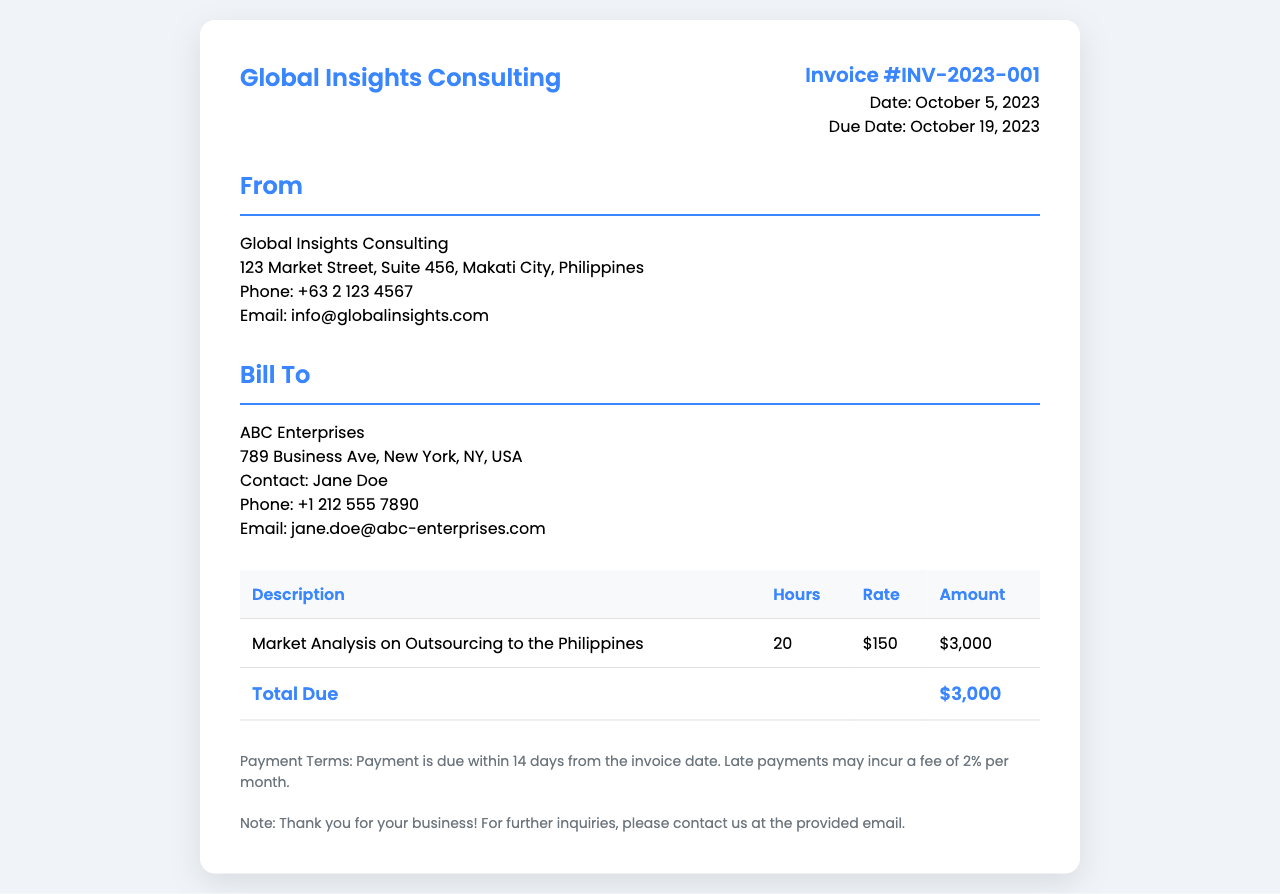what is the invoice number? The invoice number is found in the invoice details section, listed as Invoice #INV-2023-001.
Answer: Invoice #INV-2023-001 who is the bill to? The "Bill To" section identifies the client as ABC Enterprises.
Answer: ABC Enterprises what is the total amount due? The total amount due is the final amount listed in the invoice table under "Total Due," which is $3,000.
Answer: $3,000 how many hours were worked? The hours worked for the market analysis service are mentioned in the "Hours" column of the invoice.
Answer: 20 what is the rate per hour? The rate per hour for consulting services is stated in the "Rate" column of the invoice.
Answer: $150 what is the due date for the invoice? The due date is specifically mentioned in the invoice details section.
Answer: October 19, 2023 what service was provided? The description in the invoice specifies the service provided as "Market Analysis on Outsourcing to the Philippines."
Answer: Market Analysis on Outsourcing to the Philippines what are the payment terms? The payment terms are specified in a section of the document, outlining the conditions for payment.
Answer: Payment is due within 14 days from the invoice date who is the contact person for ABC Enterprises? The contact person for ABC Enterprises is mentioned in the client details section.
Answer: Jane Doe 